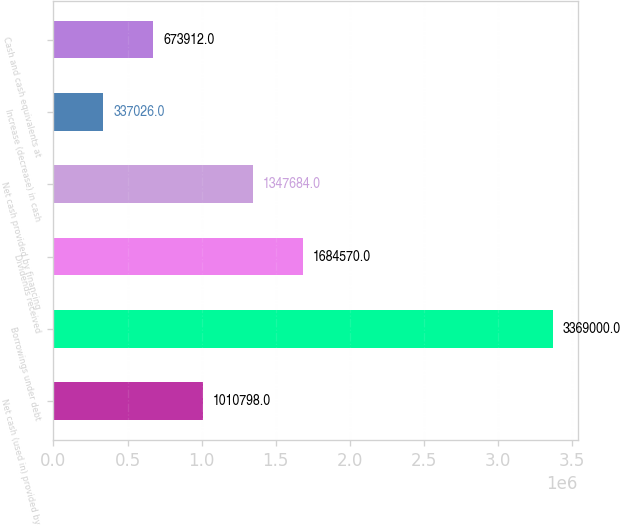<chart> <loc_0><loc_0><loc_500><loc_500><bar_chart><fcel>Net cash (used in) provided by<fcel>Borrowings under debt<fcel>Dividends received<fcel>Net cash provided by financing<fcel>Increase (decrease) in cash<fcel>Cash and cash equivalents at<nl><fcel>1.0108e+06<fcel>3.369e+06<fcel>1.68457e+06<fcel>1.34768e+06<fcel>337026<fcel>673912<nl></chart> 